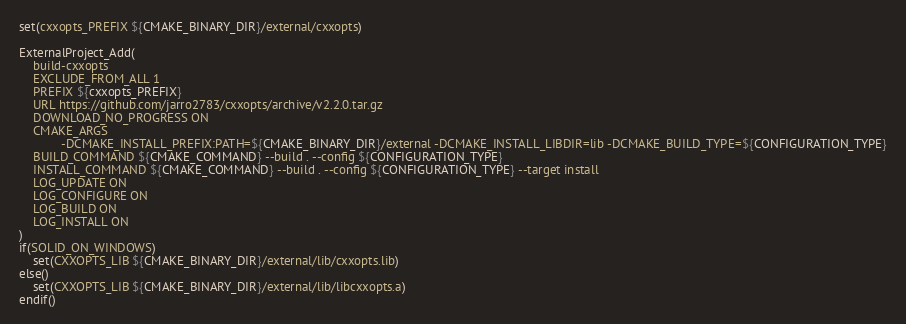Convert code to text. <code><loc_0><loc_0><loc_500><loc_500><_CMake_>set(cxxopts_PREFIX ${CMAKE_BINARY_DIR}/external/cxxopts)

ExternalProject_Add(
    build-cxxopts
    EXCLUDE_FROM_ALL 1
    PREFIX ${cxxopts_PREFIX}
    URL https://github.com/jarro2783/cxxopts/archive/v2.2.0.tar.gz
    DOWNLOAD_NO_PROGRESS ON
    CMAKE_ARGS
            -DCMAKE_INSTALL_PREFIX:PATH=${CMAKE_BINARY_DIR}/external -DCMAKE_INSTALL_LIBDIR=lib -DCMAKE_BUILD_TYPE=${CONFIGURATION_TYPE}
    BUILD_COMMAND ${CMAKE_COMMAND} --build . --config ${CONFIGURATION_TYPE}
    INSTALL_COMMAND ${CMAKE_COMMAND} --build . --config ${CONFIGURATION_TYPE} --target install
    LOG_UPDATE ON
    LOG_CONFIGURE ON
    LOG_BUILD ON
    LOG_INSTALL ON
)
if(SOLID_ON_WINDOWS)
    set(CXXOPTS_LIB ${CMAKE_BINARY_DIR}/external/lib/cxxopts.lib)
else()
    set(CXXOPTS_LIB ${CMAKE_BINARY_DIR}/external/lib/libcxxopts.a)
endif()

</code> 